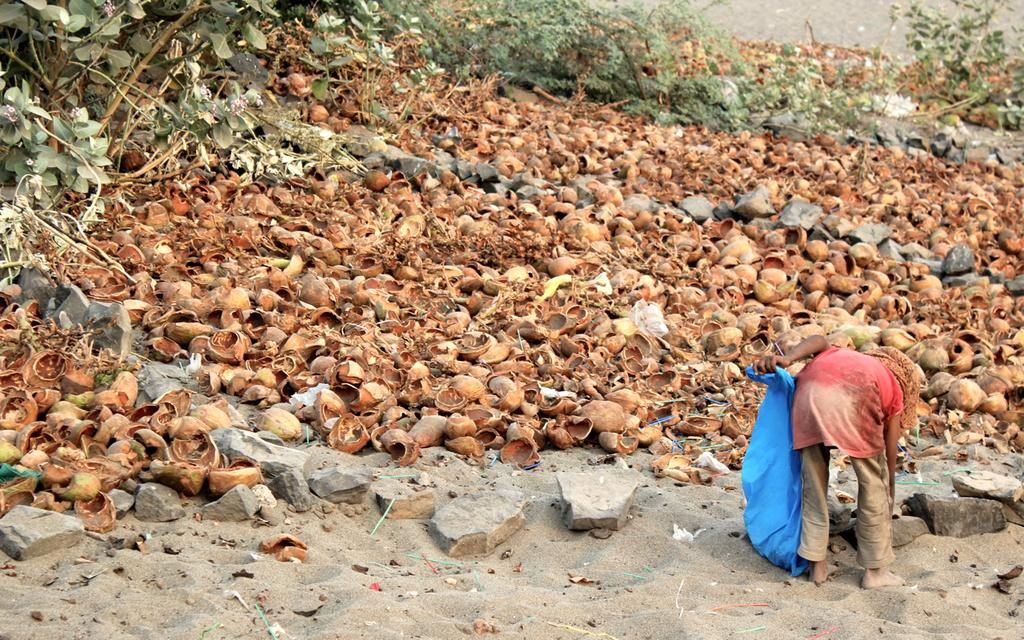What is the person in the image doing? The person is standing in the image. What is the person holding in the image? The person is holding a bag. What can be seen in the background of the image? There are trees visible in the background. What objects are present on the sand in the image? There are coconuts and stones on the sand. What type of poison can be seen on the person's hands in the image? There is no poison present on the person's hands in the image. What answer is the person looking for in the image? The image does not depict a situation where the person is looking for an answer. 